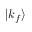<formula> <loc_0><loc_0><loc_500><loc_500>| k _ { f } \rangle</formula> 